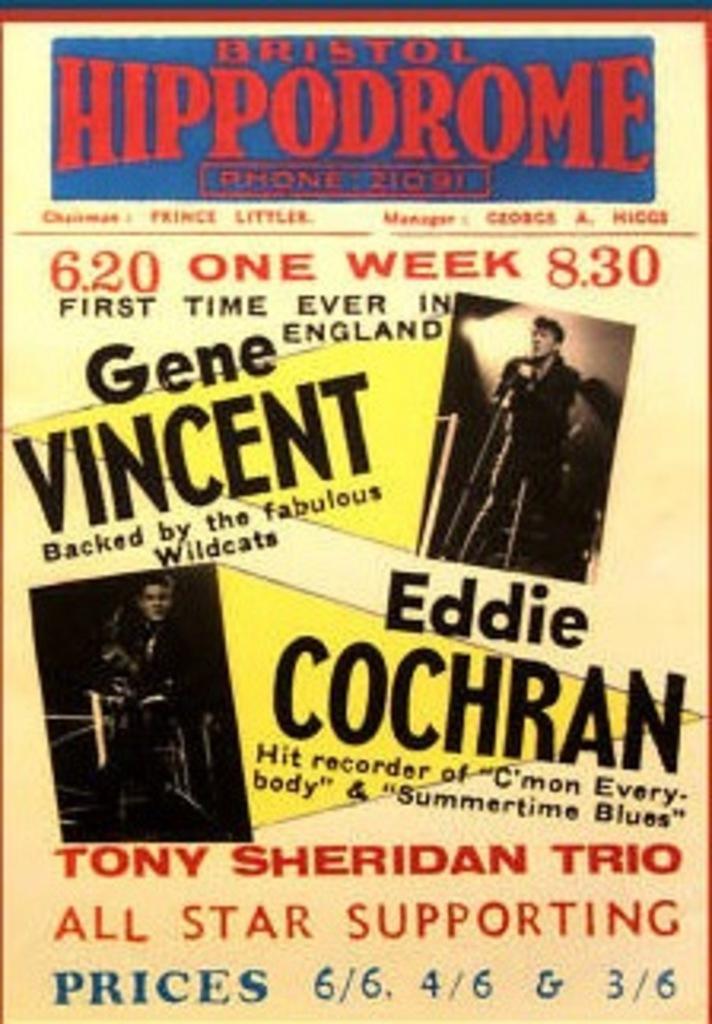Please provide a concise description of this image. In the picture I can see the poster. On the poster I can see two persons. I can see a man holding the microphone. I can see the text on the poster. 